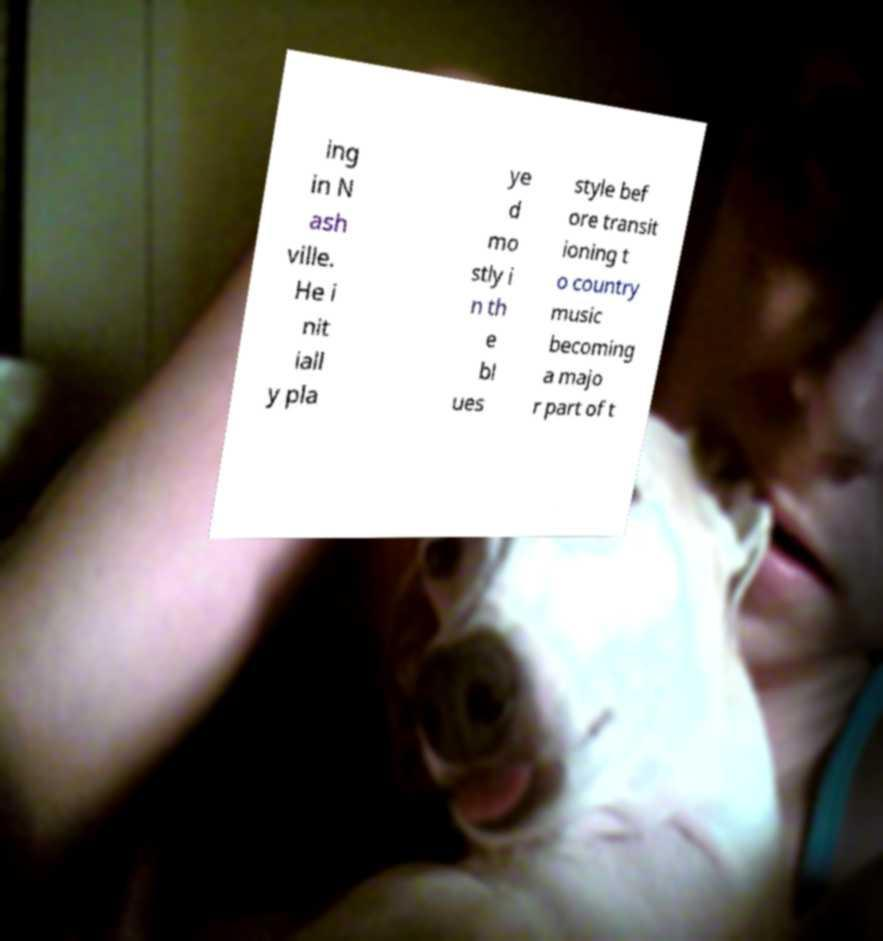Could you extract and type out the text from this image? ing in N ash ville. He i nit iall y pla ye d mo stly i n th e bl ues style bef ore transit ioning t o country music becoming a majo r part of t 